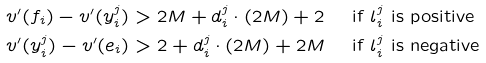<formula> <loc_0><loc_0><loc_500><loc_500>v ^ { \prime } ( f _ { i } ) - v ^ { \prime } ( y _ { i } ^ { j } ) & > 2 M + d _ { i } ^ { j } \cdot ( 2 M ) + 2 \quad \text { if    $l_{i}^{j}$    is positive} \\ v ^ { \prime } ( y _ { i } ^ { j } ) - v ^ { \prime } ( e _ { i } ) & > 2 + d _ { i } ^ { j } \cdot ( 2 M ) + 2 M \quad \text { if    $l_{i}^{j}$ is negative}</formula> 